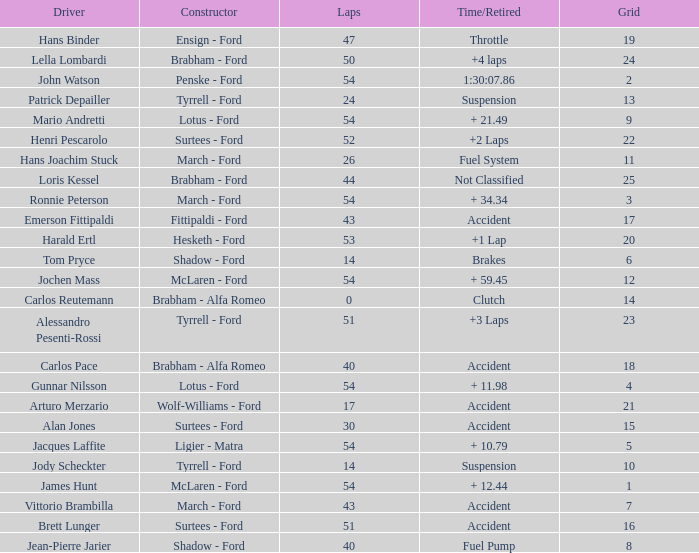How many laps did Emerson Fittipaldi do on a grid larger than 14, and when was the Time/Retired of accident? 1.0. 